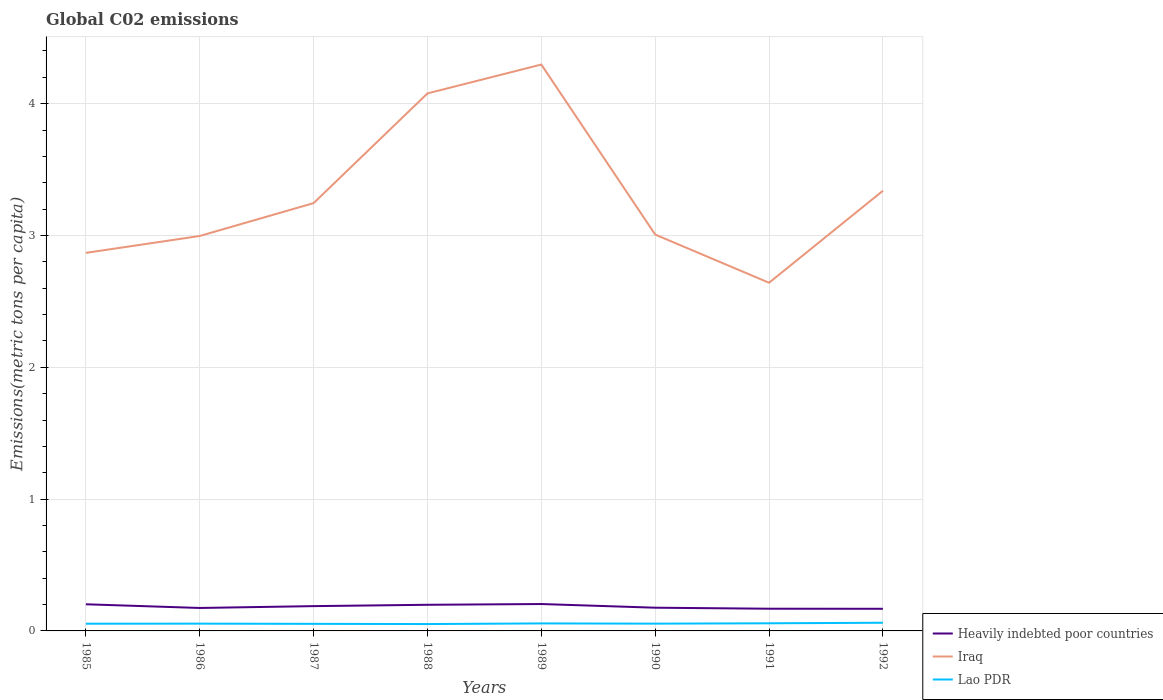How many different coloured lines are there?
Offer a very short reply. 3. Does the line corresponding to Lao PDR intersect with the line corresponding to Iraq?
Your response must be concise. No. Across all years, what is the maximum amount of CO2 emitted in in Lao PDR?
Give a very brief answer. 0.05. What is the total amount of CO2 emitted in in Lao PDR in the graph?
Your response must be concise. 0. What is the difference between the highest and the second highest amount of CO2 emitted in in Lao PDR?
Ensure brevity in your answer.  0.01. What is the difference between the highest and the lowest amount of CO2 emitted in in Lao PDR?
Ensure brevity in your answer.  3. How many lines are there?
Ensure brevity in your answer.  3. How many years are there in the graph?
Keep it short and to the point. 8. Are the values on the major ticks of Y-axis written in scientific E-notation?
Keep it short and to the point. No. Does the graph contain any zero values?
Your answer should be very brief. No. Does the graph contain grids?
Offer a terse response. Yes. How are the legend labels stacked?
Your response must be concise. Vertical. What is the title of the graph?
Keep it short and to the point. Global C02 emissions. Does "Montenegro" appear as one of the legend labels in the graph?
Your answer should be compact. No. What is the label or title of the X-axis?
Your response must be concise. Years. What is the label or title of the Y-axis?
Provide a short and direct response. Emissions(metric tons per capita). What is the Emissions(metric tons per capita) in Heavily indebted poor countries in 1985?
Offer a terse response. 0.2. What is the Emissions(metric tons per capita) of Iraq in 1985?
Provide a succinct answer. 2.87. What is the Emissions(metric tons per capita) in Lao PDR in 1985?
Provide a short and direct response. 0.05. What is the Emissions(metric tons per capita) in Heavily indebted poor countries in 1986?
Your answer should be compact. 0.17. What is the Emissions(metric tons per capita) in Iraq in 1986?
Provide a succinct answer. 3. What is the Emissions(metric tons per capita) in Lao PDR in 1986?
Provide a short and direct response. 0.06. What is the Emissions(metric tons per capita) of Heavily indebted poor countries in 1987?
Your answer should be compact. 0.19. What is the Emissions(metric tons per capita) of Iraq in 1987?
Give a very brief answer. 3.25. What is the Emissions(metric tons per capita) of Lao PDR in 1987?
Offer a very short reply. 0.05. What is the Emissions(metric tons per capita) in Heavily indebted poor countries in 1988?
Provide a succinct answer. 0.2. What is the Emissions(metric tons per capita) in Iraq in 1988?
Provide a short and direct response. 4.08. What is the Emissions(metric tons per capita) of Lao PDR in 1988?
Your response must be concise. 0.05. What is the Emissions(metric tons per capita) of Heavily indebted poor countries in 1989?
Your answer should be compact. 0.2. What is the Emissions(metric tons per capita) in Iraq in 1989?
Provide a succinct answer. 4.3. What is the Emissions(metric tons per capita) in Lao PDR in 1989?
Make the answer very short. 0.06. What is the Emissions(metric tons per capita) in Heavily indebted poor countries in 1990?
Offer a very short reply. 0.18. What is the Emissions(metric tons per capita) of Iraq in 1990?
Ensure brevity in your answer.  3.01. What is the Emissions(metric tons per capita) in Lao PDR in 1990?
Give a very brief answer. 0.06. What is the Emissions(metric tons per capita) of Heavily indebted poor countries in 1991?
Provide a short and direct response. 0.17. What is the Emissions(metric tons per capita) of Iraq in 1991?
Make the answer very short. 2.64. What is the Emissions(metric tons per capita) in Lao PDR in 1991?
Provide a succinct answer. 0.06. What is the Emissions(metric tons per capita) of Heavily indebted poor countries in 1992?
Offer a terse response. 0.17. What is the Emissions(metric tons per capita) in Iraq in 1992?
Provide a succinct answer. 3.34. What is the Emissions(metric tons per capita) in Lao PDR in 1992?
Offer a terse response. 0.06. Across all years, what is the maximum Emissions(metric tons per capita) of Heavily indebted poor countries?
Make the answer very short. 0.2. Across all years, what is the maximum Emissions(metric tons per capita) in Iraq?
Offer a terse response. 4.3. Across all years, what is the maximum Emissions(metric tons per capita) of Lao PDR?
Provide a succinct answer. 0.06. Across all years, what is the minimum Emissions(metric tons per capita) of Heavily indebted poor countries?
Offer a terse response. 0.17. Across all years, what is the minimum Emissions(metric tons per capita) of Iraq?
Provide a short and direct response. 2.64. Across all years, what is the minimum Emissions(metric tons per capita) of Lao PDR?
Provide a short and direct response. 0.05. What is the total Emissions(metric tons per capita) in Heavily indebted poor countries in the graph?
Offer a terse response. 1.48. What is the total Emissions(metric tons per capita) of Iraq in the graph?
Your answer should be compact. 26.47. What is the total Emissions(metric tons per capita) in Lao PDR in the graph?
Provide a short and direct response. 0.45. What is the difference between the Emissions(metric tons per capita) of Heavily indebted poor countries in 1985 and that in 1986?
Ensure brevity in your answer.  0.03. What is the difference between the Emissions(metric tons per capita) in Iraq in 1985 and that in 1986?
Offer a terse response. -0.13. What is the difference between the Emissions(metric tons per capita) of Lao PDR in 1985 and that in 1986?
Offer a terse response. -0. What is the difference between the Emissions(metric tons per capita) in Heavily indebted poor countries in 1985 and that in 1987?
Your answer should be very brief. 0.01. What is the difference between the Emissions(metric tons per capita) of Iraq in 1985 and that in 1987?
Ensure brevity in your answer.  -0.38. What is the difference between the Emissions(metric tons per capita) of Lao PDR in 1985 and that in 1987?
Your response must be concise. 0. What is the difference between the Emissions(metric tons per capita) in Heavily indebted poor countries in 1985 and that in 1988?
Your answer should be compact. 0. What is the difference between the Emissions(metric tons per capita) of Iraq in 1985 and that in 1988?
Make the answer very short. -1.21. What is the difference between the Emissions(metric tons per capita) in Lao PDR in 1985 and that in 1988?
Keep it short and to the point. 0. What is the difference between the Emissions(metric tons per capita) of Heavily indebted poor countries in 1985 and that in 1989?
Your answer should be very brief. -0. What is the difference between the Emissions(metric tons per capita) in Iraq in 1985 and that in 1989?
Your answer should be very brief. -1.43. What is the difference between the Emissions(metric tons per capita) of Lao PDR in 1985 and that in 1989?
Make the answer very short. -0. What is the difference between the Emissions(metric tons per capita) of Heavily indebted poor countries in 1985 and that in 1990?
Provide a short and direct response. 0.03. What is the difference between the Emissions(metric tons per capita) of Iraq in 1985 and that in 1990?
Offer a terse response. -0.14. What is the difference between the Emissions(metric tons per capita) of Lao PDR in 1985 and that in 1990?
Provide a succinct answer. -0. What is the difference between the Emissions(metric tons per capita) of Heavily indebted poor countries in 1985 and that in 1991?
Ensure brevity in your answer.  0.03. What is the difference between the Emissions(metric tons per capita) in Iraq in 1985 and that in 1991?
Give a very brief answer. 0.23. What is the difference between the Emissions(metric tons per capita) in Lao PDR in 1985 and that in 1991?
Offer a terse response. -0. What is the difference between the Emissions(metric tons per capita) of Heavily indebted poor countries in 1985 and that in 1992?
Offer a terse response. 0.03. What is the difference between the Emissions(metric tons per capita) in Iraq in 1985 and that in 1992?
Provide a short and direct response. -0.47. What is the difference between the Emissions(metric tons per capita) of Lao PDR in 1985 and that in 1992?
Provide a succinct answer. -0.01. What is the difference between the Emissions(metric tons per capita) of Heavily indebted poor countries in 1986 and that in 1987?
Make the answer very short. -0.01. What is the difference between the Emissions(metric tons per capita) in Iraq in 1986 and that in 1987?
Provide a short and direct response. -0.25. What is the difference between the Emissions(metric tons per capita) of Lao PDR in 1986 and that in 1987?
Your answer should be very brief. 0. What is the difference between the Emissions(metric tons per capita) of Heavily indebted poor countries in 1986 and that in 1988?
Give a very brief answer. -0.02. What is the difference between the Emissions(metric tons per capita) of Iraq in 1986 and that in 1988?
Your answer should be compact. -1.08. What is the difference between the Emissions(metric tons per capita) in Lao PDR in 1986 and that in 1988?
Make the answer very short. 0. What is the difference between the Emissions(metric tons per capita) of Heavily indebted poor countries in 1986 and that in 1989?
Your answer should be very brief. -0.03. What is the difference between the Emissions(metric tons per capita) of Iraq in 1986 and that in 1989?
Offer a very short reply. -1.3. What is the difference between the Emissions(metric tons per capita) of Lao PDR in 1986 and that in 1989?
Your answer should be very brief. -0. What is the difference between the Emissions(metric tons per capita) of Heavily indebted poor countries in 1986 and that in 1990?
Provide a succinct answer. -0. What is the difference between the Emissions(metric tons per capita) in Iraq in 1986 and that in 1990?
Your response must be concise. -0.01. What is the difference between the Emissions(metric tons per capita) of Heavily indebted poor countries in 1986 and that in 1991?
Your response must be concise. 0.01. What is the difference between the Emissions(metric tons per capita) in Iraq in 1986 and that in 1991?
Give a very brief answer. 0.35. What is the difference between the Emissions(metric tons per capita) of Lao PDR in 1986 and that in 1991?
Your response must be concise. -0. What is the difference between the Emissions(metric tons per capita) of Heavily indebted poor countries in 1986 and that in 1992?
Provide a short and direct response. 0.01. What is the difference between the Emissions(metric tons per capita) of Iraq in 1986 and that in 1992?
Your response must be concise. -0.34. What is the difference between the Emissions(metric tons per capita) of Lao PDR in 1986 and that in 1992?
Ensure brevity in your answer.  -0.01. What is the difference between the Emissions(metric tons per capita) in Heavily indebted poor countries in 1987 and that in 1988?
Your answer should be very brief. -0.01. What is the difference between the Emissions(metric tons per capita) of Iraq in 1987 and that in 1988?
Your response must be concise. -0.83. What is the difference between the Emissions(metric tons per capita) of Lao PDR in 1987 and that in 1988?
Give a very brief answer. 0. What is the difference between the Emissions(metric tons per capita) in Heavily indebted poor countries in 1987 and that in 1989?
Offer a very short reply. -0.02. What is the difference between the Emissions(metric tons per capita) of Iraq in 1987 and that in 1989?
Make the answer very short. -1.05. What is the difference between the Emissions(metric tons per capita) in Lao PDR in 1987 and that in 1989?
Offer a very short reply. -0. What is the difference between the Emissions(metric tons per capita) of Heavily indebted poor countries in 1987 and that in 1990?
Give a very brief answer. 0.01. What is the difference between the Emissions(metric tons per capita) of Iraq in 1987 and that in 1990?
Your response must be concise. 0.24. What is the difference between the Emissions(metric tons per capita) in Lao PDR in 1987 and that in 1990?
Ensure brevity in your answer.  -0. What is the difference between the Emissions(metric tons per capita) of Heavily indebted poor countries in 1987 and that in 1991?
Make the answer very short. 0.02. What is the difference between the Emissions(metric tons per capita) of Iraq in 1987 and that in 1991?
Make the answer very short. 0.6. What is the difference between the Emissions(metric tons per capita) in Lao PDR in 1987 and that in 1991?
Keep it short and to the point. -0. What is the difference between the Emissions(metric tons per capita) of Heavily indebted poor countries in 1987 and that in 1992?
Offer a very short reply. 0.02. What is the difference between the Emissions(metric tons per capita) of Iraq in 1987 and that in 1992?
Ensure brevity in your answer.  -0.09. What is the difference between the Emissions(metric tons per capita) of Lao PDR in 1987 and that in 1992?
Ensure brevity in your answer.  -0.01. What is the difference between the Emissions(metric tons per capita) in Heavily indebted poor countries in 1988 and that in 1989?
Ensure brevity in your answer.  -0.01. What is the difference between the Emissions(metric tons per capita) of Iraq in 1988 and that in 1989?
Make the answer very short. -0.22. What is the difference between the Emissions(metric tons per capita) of Lao PDR in 1988 and that in 1989?
Keep it short and to the point. -0. What is the difference between the Emissions(metric tons per capita) of Heavily indebted poor countries in 1988 and that in 1990?
Provide a short and direct response. 0.02. What is the difference between the Emissions(metric tons per capita) of Iraq in 1988 and that in 1990?
Keep it short and to the point. 1.07. What is the difference between the Emissions(metric tons per capita) in Lao PDR in 1988 and that in 1990?
Your response must be concise. -0. What is the difference between the Emissions(metric tons per capita) of Heavily indebted poor countries in 1988 and that in 1991?
Ensure brevity in your answer.  0.03. What is the difference between the Emissions(metric tons per capita) of Iraq in 1988 and that in 1991?
Give a very brief answer. 1.44. What is the difference between the Emissions(metric tons per capita) in Lao PDR in 1988 and that in 1991?
Provide a succinct answer. -0.01. What is the difference between the Emissions(metric tons per capita) in Heavily indebted poor countries in 1988 and that in 1992?
Offer a terse response. 0.03. What is the difference between the Emissions(metric tons per capita) in Iraq in 1988 and that in 1992?
Keep it short and to the point. 0.74. What is the difference between the Emissions(metric tons per capita) in Lao PDR in 1988 and that in 1992?
Your answer should be very brief. -0.01. What is the difference between the Emissions(metric tons per capita) of Heavily indebted poor countries in 1989 and that in 1990?
Ensure brevity in your answer.  0.03. What is the difference between the Emissions(metric tons per capita) of Iraq in 1989 and that in 1990?
Ensure brevity in your answer.  1.29. What is the difference between the Emissions(metric tons per capita) in Lao PDR in 1989 and that in 1990?
Provide a succinct answer. 0. What is the difference between the Emissions(metric tons per capita) of Heavily indebted poor countries in 1989 and that in 1991?
Ensure brevity in your answer.  0.04. What is the difference between the Emissions(metric tons per capita) of Iraq in 1989 and that in 1991?
Make the answer very short. 1.66. What is the difference between the Emissions(metric tons per capita) of Lao PDR in 1989 and that in 1991?
Provide a short and direct response. -0. What is the difference between the Emissions(metric tons per capita) in Heavily indebted poor countries in 1989 and that in 1992?
Make the answer very short. 0.04. What is the difference between the Emissions(metric tons per capita) in Iraq in 1989 and that in 1992?
Your answer should be very brief. 0.96. What is the difference between the Emissions(metric tons per capita) of Lao PDR in 1989 and that in 1992?
Give a very brief answer. -0.01. What is the difference between the Emissions(metric tons per capita) in Heavily indebted poor countries in 1990 and that in 1991?
Your response must be concise. 0.01. What is the difference between the Emissions(metric tons per capita) of Iraq in 1990 and that in 1991?
Your answer should be compact. 0.37. What is the difference between the Emissions(metric tons per capita) of Lao PDR in 1990 and that in 1991?
Keep it short and to the point. -0. What is the difference between the Emissions(metric tons per capita) of Heavily indebted poor countries in 1990 and that in 1992?
Give a very brief answer. 0.01. What is the difference between the Emissions(metric tons per capita) in Iraq in 1990 and that in 1992?
Give a very brief answer. -0.33. What is the difference between the Emissions(metric tons per capita) in Lao PDR in 1990 and that in 1992?
Make the answer very short. -0.01. What is the difference between the Emissions(metric tons per capita) in Heavily indebted poor countries in 1991 and that in 1992?
Keep it short and to the point. 0. What is the difference between the Emissions(metric tons per capita) in Iraq in 1991 and that in 1992?
Your answer should be compact. -0.7. What is the difference between the Emissions(metric tons per capita) of Lao PDR in 1991 and that in 1992?
Make the answer very short. -0. What is the difference between the Emissions(metric tons per capita) in Heavily indebted poor countries in 1985 and the Emissions(metric tons per capita) in Iraq in 1986?
Ensure brevity in your answer.  -2.79. What is the difference between the Emissions(metric tons per capita) in Heavily indebted poor countries in 1985 and the Emissions(metric tons per capita) in Lao PDR in 1986?
Offer a very short reply. 0.15. What is the difference between the Emissions(metric tons per capita) of Iraq in 1985 and the Emissions(metric tons per capita) of Lao PDR in 1986?
Provide a succinct answer. 2.81. What is the difference between the Emissions(metric tons per capita) of Heavily indebted poor countries in 1985 and the Emissions(metric tons per capita) of Iraq in 1987?
Offer a terse response. -3.04. What is the difference between the Emissions(metric tons per capita) of Heavily indebted poor countries in 1985 and the Emissions(metric tons per capita) of Lao PDR in 1987?
Your response must be concise. 0.15. What is the difference between the Emissions(metric tons per capita) of Iraq in 1985 and the Emissions(metric tons per capita) of Lao PDR in 1987?
Your response must be concise. 2.81. What is the difference between the Emissions(metric tons per capita) of Heavily indebted poor countries in 1985 and the Emissions(metric tons per capita) of Iraq in 1988?
Your answer should be compact. -3.88. What is the difference between the Emissions(metric tons per capita) in Iraq in 1985 and the Emissions(metric tons per capita) in Lao PDR in 1988?
Provide a short and direct response. 2.82. What is the difference between the Emissions(metric tons per capita) in Heavily indebted poor countries in 1985 and the Emissions(metric tons per capita) in Iraq in 1989?
Your response must be concise. -4.09. What is the difference between the Emissions(metric tons per capita) of Heavily indebted poor countries in 1985 and the Emissions(metric tons per capita) of Lao PDR in 1989?
Offer a terse response. 0.15. What is the difference between the Emissions(metric tons per capita) in Iraq in 1985 and the Emissions(metric tons per capita) in Lao PDR in 1989?
Give a very brief answer. 2.81. What is the difference between the Emissions(metric tons per capita) in Heavily indebted poor countries in 1985 and the Emissions(metric tons per capita) in Iraq in 1990?
Make the answer very short. -2.8. What is the difference between the Emissions(metric tons per capita) of Heavily indebted poor countries in 1985 and the Emissions(metric tons per capita) of Lao PDR in 1990?
Offer a very short reply. 0.15. What is the difference between the Emissions(metric tons per capita) of Iraq in 1985 and the Emissions(metric tons per capita) of Lao PDR in 1990?
Provide a succinct answer. 2.81. What is the difference between the Emissions(metric tons per capita) of Heavily indebted poor countries in 1985 and the Emissions(metric tons per capita) of Iraq in 1991?
Your response must be concise. -2.44. What is the difference between the Emissions(metric tons per capita) of Heavily indebted poor countries in 1985 and the Emissions(metric tons per capita) of Lao PDR in 1991?
Your answer should be compact. 0.14. What is the difference between the Emissions(metric tons per capita) in Iraq in 1985 and the Emissions(metric tons per capita) in Lao PDR in 1991?
Provide a short and direct response. 2.81. What is the difference between the Emissions(metric tons per capita) of Heavily indebted poor countries in 1985 and the Emissions(metric tons per capita) of Iraq in 1992?
Make the answer very short. -3.14. What is the difference between the Emissions(metric tons per capita) of Heavily indebted poor countries in 1985 and the Emissions(metric tons per capita) of Lao PDR in 1992?
Offer a very short reply. 0.14. What is the difference between the Emissions(metric tons per capita) of Iraq in 1985 and the Emissions(metric tons per capita) of Lao PDR in 1992?
Provide a short and direct response. 2.81. What is the difference between the Emissions(metric tons per capita) in Heavily indebted poor countries in 1986 and the Emissions(metric tons per capita) in Iraq in 1987?
Provide a short and direct response. -3.07. What is the difference between the Emissions(metric tons per capita) in Heavily indebted poor countries in 1986 and the Emissions(metric tons per capita) in Lao PDR in 1987?
Give a very brief answer. 0.12. What is the difference between the Emissions(metric tons per capita) of Iraq in 1986 and the Emissions(metric tons per capita) of Lao PDR in 1987?
Offer a terse response. 2.94. What is the difference between the Emissions(metric tons per capita) in Heavily indebted poor countries in 1986 and the Emissions(metric tons per capita) in Iraq in 1988?
Your response must be concise. -3.9. What is the difference between the Emissions(metric tons per capita) in Heavily indebted poor countries in 1986 and the Emissions(metric tons per capita) in Lao PDR in 1988?
Your answer should be very brief. 0.12. What is the difference between the Emissions(metric tons per capita) of Iraq in 1986 and the Emissions(metric tons per capita) of Lao PDR in 1988?
Your answer should be very brief. 2.94. What is the difference between the Emissions(metric tons per capita) in Heavily indebted poor countries in 1986 and the Emissions(metric tons per capita) in Iraq in 1989?
Provide a succinct answer. -4.12. What is the difference between the Emissions(metric tons per capita) in Heavily indebted poor countries in 1986 and the Emissions(metric tons per capita) in Lao PDR in 1989?
Your answer should be compact. 0.12. What is the difference between the Emissions(metric tons per capita) of Iraq in 1986 and the Emissions(metric tons per capita) of Lao PDR in 1989?
Offer a terse response. 2.94. What is the difference between the Emissions(metric tons per capita) in Heavily indebted poor countries in 1986 and the Emissions(metric tons per capita) in Iraq in 1990?
Provide a short and direct response. -2.83. What is the difference between the Emissions(metric tons per capita) of Heavily indebted poor countries in 1986 and the Emissions(metric tons per capita) of Lao PDR in 1990?
Your answer should be compact. 0.12. What is the difference between the Emissions(metric tons per capita) of Iraq in 1986 and the Emissions(metric tons per capita) of Lao PDR in 1990?
Give a very brief answer. 2.94. What is the difference between the Emissions(metric tons per capita) in Heavily indebted poor countries in 1986 and the Emissions(metric tons per capita) in Iraq in 1991?
Provide a short and direct response. -2.47. What is the difference between the Emissions(metric tons per capita) of Heavily indebted poor countries in 1986 and the Emissions(metric tons per capita) of Lao PDR in 1991?
Give a very brief answer. 0.12. What is the difference between the Emissions(metric tons per capita) in Iraq in 1986 and the Emissions(metric tons per capita) in Lao PDR in 1991?
Make the answer very short. 2.94. What is the difference between the Emissions(metric tons per capita) in Heavily indebted poor countries in 1986 and the Emissions(metric tons per capita) in Iraq in 1992?
Make the answer very short. -3.17. What is the difference between the Emissions(metric tons per capita) in Heavily indebted poor countries in 1986 and the Emissions(metric tons per capita) in Lao PDR in 1992?
Give a very brief answer. 0.11. What is the difference between the Emissions(metric tons per capita) of Iraq in 1986 and the Emissions(metric tons per capita) of Lao PDR in 1992?
Make the answer very short. 2.93. What is the difference between the Emissions(metric tons per capita) in Heavily indebted poor countries in 1987 and the Emissions(metric tons per capita) in Iraq in 1988?
Your answer should be very brief. -3.89. What is the difference between the Emissions(metric tons per capita) of Heavily indebted poor countries in 1987 and the Emissions(metric tons per capita) of Lao PDR in 1988?
Your answer should be very brief. 0.14. What is the difference between the Emissions(metric tons per capita) in Iraq in 1987 and the Emissions(metric tons per capita) in Lao PDR in 1988?
Ensure brevity in your answer.  3.19. What is the difference between the Emissions(metric tons per capita) in Heavily indebted poor countries in 1987 and the Emissions(metric tons per capita) in Iraq in 1989?
Offer a very short reply. -4.11. What is the difference between the Emissions(metric tons per capita) in Heavily indebted poor countries in 1987 and the Emissions(metric tons per capita) in Lao PDR in 1989?
Provide a short and direct response. 0.13. What is the difference between the Emissions(metric tons per capita) of Iraq in 1987 and the Emissions(metric tons per capita) of Lao PDR in 1989?
Make the answer very short. 3.19. What is the difference between the Emissions(metric tons per capita) in Heavily indebted poor countries in 1987 and the Emissions(metric tons per capita) in Iraq in 1990?
Offer a terse response. -2.82. What is the difference between the Emissions(metric tons per capita) of Heavily indebted poor countries in 1987 and the Emissions(metric tons per capita) of Lao PDR in 1990?
Provide a short and direct response. 0.13. What is the difference between the Emissions(metric tons per capita) of Iraq in 1987 and the Emissions(metric tons per capita) of Lao PDR in 1990?
Give a very brief answer. 3.19. What is the difference between the Emissions(metric tons per capita) of Heavily indebted poor countries in 1987 and the Emissions(metric tons per capita) of Iraq in 1991?
Give a very brief answer. -2.45. What is the difference between the Emissions(metric tons per capita) in Heavily indebted poor countries in 1987 and the Emissions(metric tons per capita) in Lao PDR in 1991?
Offer a terse response. 0.13. What is the difference between the Emissions(metric tons per capita) in Iraq in 1987 and the Emissions(metric tons per capita) in Lao PDR in 1991?
Ensure brevity in your answer.  3.19. What is the difference between the Emissions(metric tons per capita) in Heavily indebted poor countries in 1987 and the Emissions(metric tons per capita) in Iraq in 1992?
Your answer should be very brief. -3.15. What is the difference between the Emissions(metric tons per capita) of Heavily indebted poor countries in 1987 and the Emissions(metric tons per capita) of Lao PDR in 1992?
Provide a short and direct response. 0.13. What is the difference between the Emissions(metric tons per capita) in Iraq in 1987 and the Emissions(metric tons per capita) in Lao PDR in 1992?
Offer a very short reply. 3.18. What is the difference between the Emissions(metric tons per capita) in Heavily indebted poor countries in 1988 and the Emissions(metric tons per capita) in Iraq in 1989?
Offer a very short reply. -4.1. What is the difference between the Emissions(metric tons per capita) of Heavily indebted poor countries in 1988 and the Emissions(metric tons per capita) of Lao PDR in 1989?
Offer a very short reply. 0.14. What is the difference between the Emissions(metric tons per capita) in Iraq in 1988 and the Emissions(metric tons per capita) in Lao PDR in 1989?
Your response must be concise. 4.02. What is the difference between the Emissions(metric tons per capita) in Heavily indebted poor countries in 1988 and the Emissions(metric tons per capita) in Iraq in 1990?
Offer a very short reply. -2.81. What is the difference between the Emissions(metric tons per capita) of Heavily indebted poor countries in 1988 and the Emissions(metric tons per capita) of Lao PDR in 1990?
Offer a very short reply. 0.14. What is the difference between the Emissions(metric tons per capita) in Iraq in 1988 and the Emissions(metric tons per capita) in Lao PDR in 1990?
Offer a terse response. 4.02. What is the difference between the Emissions(metric tons per capita) in Heavily indebted poor countries in 1988 and the Emissions(metric tons per capita) in Iraq in 1991?
Give a very brief answer. -2.44. What is the difference between the Emissions(metric tons per capita) of Heavily indebted poor countries in 1988 and the Emissions(metric tons per capita) of Lao PDR in 1991?
Your answer should be compact. 0.14. What is the difference between the Emissions(metric tons per capita) of Iraq in 1988 and the Emissions(metric tons per capita) of Lao PDR in 1991?
Provide a short and direct response. 4.02. What is the difference between the Emissions(metric tons per capita) in Heavily indebted poor countries in 1988 and the Emissions(metric tons per capita) in Iraq in 1992?
Provide a short and direct response. -3.14. What is the difference between the Emissions(metric tons per capita) of Heavily indebted poor countries in 1988 and the Emissions(metric tons per capita) of Lao PDR in 1992?
Offer a terse response. 0.14. What is the difference between the Emissions(metric tons per capita) in Iraq in 1988 and the Emissions(metric tons per capita) in Lao PDR in 1992?
Offer a terse response. 4.02. What is the difference between the Emissions(metric tons per capita) of Heavily indebted poor countries in 1989 and the Emissions(metric tons per capita) of Iraq in 1990?
Your answer should be very brief. -2.8. What is the difference between the Emissions(metric tons per capita) of Heavily indebted poor countries in 1989 and the Emissions(metric tons per capita) of Lao PDR in 1990?
Give a very brief answer. 0.15. What is the difference between the Emissions(metric tons per capita) of Iraq in 1989 and the Emissions(metric tons per capita) of Lao PDR in 1990?
Keep it short and to the point. 4.24. What is the difference between the Emissions(metric tons per capita) in Heavily indebted poor countries in 1989 and the Emissions(metric tons per capita) in Iraq in 1991?
Your answer should be compact. -2.44. What is the difference between the Emissions(metric tons per capita) in Heavily indebted poor countries in 1989 and the Emissions(metric tons per capita) in Lao PDR in 1991?
Offer a terse response. 0.15. What is the difference between the Emissions(metric tons per capita) of Iraq in 1989 and the Emissions(metric tons per capita) of Lao PDR in 1991?
Offer a terse response. 4.24. What is the difference between the Emissions(metric tons per capita) in Heavily indebted poor countries in 1989 and the Emissions(metric tons per capita) in Iraq in 1992?
Your answer should be compact. -3.14. What is the difference between the Emissions(metric tons per capita) of Heavily indebted poor countries in 1989 and the Emissions(metric tons per capita) of Lao PDR in 1992?
Your answer should be very brief. 0.14. What is the difference between the Emissions(metric tons per capita) in Iraq in 1989 and the Emissions(metric tons per capita) in Lao PDR in 1992?
Your answer should be compact. 4.23. What is the difference between the Emissions(metric tons per capita) of Heavily indebted poor countries in 1990 and the Emissions(metric tons per capita) of Iraq in 1991?
Offer a terse response. -2.47. What is the difference between the Emissions(metric tons per capita) of Heavily indebted poor countries in 1990 and the Emissions(metric tons per capita) of Lao PDR in 1991?
Provide a succinct answer. 0.12. What is the difference between the Emissions(metric tons per capita) in Iraq in 1990 and the Emissions(metric tons per capita) in Lao PDR in 1991?
Provide a short and direct response. 2.95. What is the difference between the Emissions(metric tons per capita) in Heavily indebted poor countries in 1990 and the Emissions(metric tons per capita) in Iraq in 1992?
Give a very brief answer. -3.16. What is the difference between the Emissions(metric tons per capita) in Heavily indebted poor countries in 1990 and the Emissions(metric tons per capita) in Lao PDR in 1992?
Your answer should be very brief. 0.11. What is the difference between the Emissions(metric tons per capita) in Iraq in 1990 and the Emissions(metric tons per capita) in Lao PDR in 1992?
Your answer should be very brief. 2.94. What is the difference between the Emissions(metric tons per capita) of Heavily indebted poor countries in 1991 and the Emissions(metric tons per capita) of Iraq in 1992?
Your answer should be compact. -3.17. What is the difference between the Emissions(metric tons per capita) of Heavily indebted poor countries in 1991 and the Emissions(metric tons per capita) of Lao PDR in 1992?
Give a very brief answer. 0.11. What is the difference between the Emissions(metric tons per capita) of Iraq in 1991 and the Emissions(metric tons per capita) of Lao PDR in 1992?
Offer a terse response. 2.58. What is the average Emissions(metric tons per capita) in Heavily indebted poor countries per year?
Offer a terse response. 0.18. What is the average Emissions(metric tons per capita) in Iraq per year?
Your answer should be very brief. 3.31. What is the average Emissions(metric tons per capita) of Lao PDR per year?
Offer a very short reply. 0.06. In the year 1985, what is the difference between the Emissions(metric tons per capita) in Heavily indebted poor countries and Emissions(metric tons per capita) in Iraq?
Your answer should be compact. -2.67. In the year 1985, what is the difference between the Emissions(metric tons per capita) in Heavily indebted poor countries and Emissions(metric tons per capita) in Lao PDR?
Your answer should be very brief. 0.15. In the year 1985, what is the difference between the Emissions(metric tons per capita) of Iraq and Emissions(metric tons per capita) of Lao PDR?
Your answer should be very brief. 2.81. In the year 1986, what is the difference between the Emissions(metric tons per capita) of Heavily indebted poor countries and Emissions(metric tons per capita) of Iraq?
Offer a terse response. -2.82. In the year 1986, what is the difference between the Emissions(metric tons per capita) in Heavily indebted poor countries and Emissions(metric tons per capita) in Lao PDR?
Keep it short and to the point. 0.12. In the year 1986, what is the difference between the Emissions(metric tons per capita) of Iraq and Emissions(metric tons per capita) of Lao PDR?
Your response must be concise. 2.94. In the year 1987, what is the difference between the Emissions(metric tons per capita) of Heavily indebted poor countries and Emissions(metric tons per capita) of Iraq?
Ensure brevity in your answer.  -3.06. In the year 1987, what is the difference between the Emissions(metric tons per capita) of Heavily indebted poor countries and Emissions(metric tons per capita) of Lao PDR?
Keep it short and to the point. 0.13. In the year 1987, what is the difference between the Emissions(metric tons per capita) of Iraq and Emissions(metric tons per capita) of Lao PDR?
Provide a short and direct response. 3.19. In the year 1988, what is the difference between the Emissions(metric tons per capita) in Heavily indebted poor countries and Emissions(metric tons per capita) in Iraq?
Offer a terse response. -3.88. In the year 1988, what is the difference between the Emissions(metric tons per capita) of Heavily indebted poor countries and Emissions(metric tons per capita) of Lao PDR?
Keep it short and to the point. 0.15. In the year 1988, what is the difference between the Emissions(metric tons per capita) of Iraq and Emissions(metric tons per capita) of Lao PDR?
Ensure brevity in your answer.  4.03. In the year 1989, what is the difference between the Emissions(metric tons per capita) of Heavily indebted poor countries and Emissions(metric tons per capita) of Iraq?
Provide a succinct answer. -4.09. In the year 1989, what is the difference between the Emissions(metric tons per capita) in Heavily indebted poor countries and Emissions(metric tons per capita) in Lao PDR?
Give a very brief answer. 0.15. In the year 1989, what is the difference between the Emissions(metric tons per capita) in Iraq and Emissions(metric tons per capita) in Lao PDR?
Keep it short and to the point. 4.24. In the year 1990, what is the difference between the Emissions(metric tons per capita) of Heavily indebted poor countries and Emissions(metric tons per capita) of Iraq?
Your answer should be very brief. -2.83. In the year 1990, what is the difference between the Emissions(metric tons per capita) of Heavily indebted poor countries and Emissions(metric tons per capita) of Lao PDR?
Offer a terse response. 0.12. In the year 1990, what is the difference between the Emissions(metric tons per capita) in Iraq and Emissions(metric tons per capita) in Lao PDR?
Make the answer very short. 2.95. In the year 1991, what is the difference between the Emissions(metric tons per capita) of Heavily indebted poor countries and Emissions(metric tons per capita) of Iraq?
Your answer should be compact. -2.47. In the year 1991, what is the difference between the Emissions(metric tons per capita) in Heavily indebted poor countries and Emissions(metric tons per capita) in Lao PDR?
Keep it short and to the point. 0.11. In the year 1991, what is the difference between the Emissions(metric tons per capita) of Iraq and Emissions(metric tons per capita) of Lao PDR?
Make the answer very short. 2.58. In the year 1992, what is the difference between the Emissions(metric tons per capita) in Heavily indebted poor countries and Emissions(metric tons per capita) in Iraq?
Your answer should be compact. -3.17. In the year 1992, what is the difference between the Emissions(metric tons per capita) of Heavily indebted poor countries and Emissions(metric tons per capita) of Lao PDR?
Provide a short and direct response. 0.11. In the year 1992, what is the difference between the Emissions(metric tons per capita) in Iraq and Emissions(metric tons per capita) in Lao PDR?
Offer a terse response. 3.28. What is the ratio of the Emissions(metric tons per capita) of Heavily indebted poor countries in 1985 to that in 1986?
Give a very brief answer. 1.16. What is the ratio of the Emissions(metric tons per capita) in Iraq in 1985 to that in 1986?
Give a very brief answer. 0.96. What is the ratio of the Emissions(metric tons per capita) of Lao PDR in 1985 to that in 1986?
Your response must be concise. 0.99. What is the ratio of the Emissions(metric tons per capita) in Heavily indebted poor countries in 1985 to that in 1987?
Your answer should be very brief. 1.07. What is the ratio of the Emissions(metric tons per capita) of Iraq in 1985 to that in 1987?
Make the answer very short. 0.88. What is the ratio of the Emissions(metric tons per capita) of Lao PDR in 1985 to that in 1987?
Ensure brevity in your answer.  1.02. What is the ratio of the Emissions(metric tons per capita) in Heavily indebted poor countries in 1985 to that in 1988?
Keep it short and to the point. 1.02. What is the ratio of the Emissions(metric tons per capita) of Iraq in 1985 to that in 1988?
Make the answer very short. 0.7. What is the ratio of the Emissions(metric tons per capita) of Lao PDR in 1985 to that in 1988?
Offer a very short reply. 1.05. What is the ratio of the Emissions(metric tons per capita) in Heavily indebted poor countries in 1985 to that in 1989?
Your answer should be very brief. 0.99. What is the ratio of the Emissions(metric tons per capita) of Iraq in 1985 to that in 1989?
Offer a very short reply. 0.67. What is the ratio of the Emissions(metric tons per capita) of Lao PDR in 1985 to that in 1989?
Provide a succinct answer. 0.96. What is the ratio of the Emissions(metric tons per capita) of Heavily indebted poor countries in 1985 to that in 1990?
Offer a terse response. 1.15. What is the ratio of the Emissions(metric tons per capita) of Iraq in 1985 to that in 1990?
Provide a succinct answer. 0.95. What is the ratio of the Emissions(metric tons per capita) in Lao PDR in 1985 to that in 1990?
Provide a succinct answer. 0.99. What is the ratio of the Emissions(metric tons per capita) in Heavily indebted poor countries in 1985 to that in 1991?
Your answer should be compact. 1.2. What is the ratio of the Emissions(metric tons per capita) in Iraq in 1985 to that in 1991?
Offer a terse response. 1.09. What is the ratio of the Emissions(metric tons per capita) in Lao PDR in 1985 to that in 1991?
Offer a terse response. 0.95. What is the ratio of the Emissions(metric tons per capita) in Heavily indebted poor countries in 1985 to that in 1992?
Offer a terse response. 1.2. What is the ratio of the Emissions(metric tons per capita) of Iraq in 1985 to that in 1992?
Ensure brevity in your answer.  0.86. What is the ratio of the Emissions(metric tons per capita) of Lao PDR in 1985 to that in 1992?
Provide a succinct answer. 0.88. What is the ratio of the Emissions(metric tons per capita) of Heavily indebted poor countries in 1986 to that in 1987?
Keep it short and to the point. 0.93. What is the ratio of the Emissions(metric tons per capita) in Iraq in 1986 to that in 1987?
Offer a very short reply. 0.92. What is the ratio of the Emissions(metric tons per capita) in Heavily indebted poor countries in 1986 to that in 1988?
Your answer should be very brief. 0.88. What is the ratio of the Emissions(metric tons per capita) of Iraq in 1986 to that in 1988?
Provide a succinct answer. 0.73. What is the ratio of the Emissions(metric tons per capita) in Lao PDR in 1986 to that in 1988?
Your answer should be compact. 1.06. What is the ratio of the Emissions(metric tons per capita) of Heavily indebted poor countries in 1986 to that in 1989?
Provide a short and direct response. 0.85. What is the ratio of the Emissions(metric tons per capita) of Iraq in 1986 to that in 1989?
Your answer should be very brief. 0.7. What is the ratio of the Emissions(metric tons per capita) in Heavily indebted poor countries in 1986 to that in 1990?
Make the answer very short. 0.99. What is the ratio of the Emissions(metric tons per capita) of Heavily indebted poor countries in 1986 to that in 1991?
Provide a short and direct response. 1.03. What is the ratio of the Emissions(metric tons per capita) of Iraq in 1986 to that in 1991?
Ensure brevity in your answer.  1.13. What is the ratio of the Emissions(metric tons per capita) in Lao PDR in 1986 to that in 1991?
Provide a succinct answer. 0.95. What is the ratio of the Emissions(metric tons per capita) in Heavily indebted poor countries in 1986 to that in 1992?
Provide a short and direct response. 1.04. What is the ratio of the Emissions(metric tons per capita) of Iraq in 1986 to that in 1992?
Your answer should be compact. 0.9. What is the ratio of the Emissions(metric tons per capita) in Lao PDR in 1986 to that in 1992?
Your response must be concise. 0.89. What is the ratio of the Emissions(metric tons per capita) in Heavily indebted poor countries in 1987 to that in 1988?
Give a very brief answer. 0.95. What is the ratio of the Emissions(metric tons per capita) in Iraq in 1987 to that in 1988?
Ensure brevity in your answer.  0.8. What is the ratio of the Emissions(metric tons per capita) of Lao PDR in 1987 to that in 1988?
Provide a succinct answer. 1.03. What is the ratio of the Emissions(metric tons per capita) of Heavily indebted poor countries in 1987 to that in 1989?
Make the answer very short. 0.92. What is the ratio of the Emissions(metric tons per capita) of Iraq in 1987 to that in 1989?
Offer a very short reply. 0.76. What is the ratio of the Emissions(metric tons per capita) in Lao PDR in 1987 to that in 1989?
Ensure brevity in your answer.  0.94. What is the ratio of the Emissions(metric tons per capita) of Heavily indebted poor countries in 1987 to that in 1990?
Offer a very short reply. 1.07. What is the ratio of the Emissions(metric tons per capita) of Iraq in 1987 to that in 1990?
Your response must be concise. 1.08. What is the ratio of the Emissions(metric tons per capita) in Lao PDR in 1987 to that in 1990?
Give a very brief answer. 0.97. What is the ratio of the Emissions(metric tons per capita) in Heavily indebted poor countries in 1987 to that in 1991?
Provide a succinct answer. 1.12. What is the ratio of the Emissions(metric tons per capita) of Iraq in 1987 to that in 1991?
Make the answer very short. 1.23. What is the ratio of the Emissions(metric tons per capita) of Lao PDR in 1987 to that in 1991?
Give a very brief answer. 0.93. What is the ratio of the Emissions(metric tons per capita) in Heavily indebted poor countries in 1987 to that in 1992?
Give a very brief answer. 1.12. What is the ratio of the Emissions(metric tons per capita) of Iraq in 1987 to that in 1992?
Your answer should be compact. 0.97. What is the ratio of the Emissions(metric tons per capita) of Lao PDR in 1987 to that in 1992?
Give a very brief answer. 0.87. What is the ratio of the Emissions(metric tons per capita) of Heavily indebted poor countries in 1988 to that in 1989?
Ensure brevity in your answer.  0.97. What is the ratio of the Emissions(metric tons per capita) of Iraq in 1988 to that in 1989?
Offer a terse response. 0.95. What is the ratio of the Emissions(metric tons per capita) of Lao PDR in 1988 to that in 1989?
Give a very brief answer. 0.92. What is the ratio of the Emissions(metric tons per capita) of Heavily indebted poor countries in 1988 to that in 1990?
Provide a succinct answer. 1.13. What is the ratio of the Emissions(metric tons per capita) in Iraq in 1988 to that in 1990?
Your response must be concise. 1.36. What is the ratio of the Emissions(metric tons per capita) of Lao PDR in 1988 to that in 1990?
Provide a short and direct response. 0.94. What is the ratio of the Emissions(metric tons per capita) of Heavily indebted poor countries in 1988 to that in 1991?
Provide a short and direct response. 1.18. What is the ratio of the Emissions(metric tons per capita) in Iraq in 1988 to that in 1991?
Ensure brevity in your answer.  1.54. What is the ratio of the Emissions(metric tons per capita) of Lao PDR in 1988 to that in 1991?
Your answer should be compact. 0.9. What is the ratio of the Emissions(metric tons per capita) of Heavily indebted poor countries in 1988 to that in 1992?
Your response must be concise. 1.18. What is the ratio of the Emissions(metric tons per capita) in Iraq in 1988 to that in 1992?
Keep it short and to the point. 1.22. What is the ratio of the Emissions(metric tons per capita) of Lao PDR in 1988 to that in 1992?
Offer a terse response. 0.84. What is the ratio of the Emissions(metric tons per capita) in Heavily indebted poor countries in 1989 to that in 1990?
Make the answer very short. 1.16. What is the ratio of the Emissions(metric tons per capita) in Iraq in 1989 to that in 1990?
Your answer should be very brief. 1.43. What is the ratio of the Emissions(metric tons per capita) of Lao PDR in 1989 to that in 1990?
Offer a terse response. 1.03. What is the ratio of the Emissions(metric tons per capita) of Heavily indebted poor countries in 1989 to that in 1991?
Keep it short and to the point. 1.21. What is the ratio of the Emissions(metric tons per capita) in Iraq in 1989 to that in 1991?
Make the answer very short. 1.63. What is the ratio of the Emissions(metric tons per capita) of Lao PDR in 1989 to that in 1991?
Ensure brevity in your answer.  0.98. What is the ratio of the Emissions(metric tons per capita) in Heavily indebted poor countries in 1989 to that in 1992?
Make the answer very short. 1.22. What is the ratio of the Emissions(metric tons per capita) of Iraq in 1989 to that in 1992?
Make the answer very short. 1.29. What is the ratio of the Emissions(metric tons per capita) of Lao PDR in 1989 to that in 1992?
Your answer should be very brief. 0.92. What is the ratio of the Emissions(metric tons per capita) of Heavily indebted poor countries in 1990 to that in 1991?
Offer a terse response. 1.05. What is the ratio of the Emissions(metric tons per capita) of Iraq in 1990 to that in 1991?
Make the answer very short. 1.14. What is the ratio of the Emissions(metric tons per capita) of Lao PDR in 1990 to that in 1991?
Make the answer very short. 0.95. What is the ratio of the Emissions(metric tons per capita) of Heavily indebted poor countries in 1990 to that in 1992?
Your answer should be compact. 1.05. What is the ratio of the Emissions(metric tons per capita) in Iraq in 1990 to that in 1992?
Your answer should be compact. 0.9. What is the ratio of the Emissions(metric tons per capita) in Lao PDR in 1990 to that in 1992?
Offer a terse response. 0.89. What is the ratio of the Emissions(metric tons per capita) of Iraq in 1991 to that in 1992?
Offer a very short reply. 0.79. What is the ratio of the Emissions(metric tons per capita) in Lao PDR in 1991 to that in 1992?
Ensure brevity in your answer.  0.93. What is the difference between the highest and the second highest Emissions(metric tons per capita) in Heavily indebted poor countries?
Ensure brevity in your answer.  0. What is the difference between the highest and the second highest Emissions(metric tons per capita) of Iraq?
Your response must be concise. 0.22. What is the difference between the highest and the second highest Emissions(metric tons per capita) of Lao PDR?
Your response must be concise. 0. What is the difference between the highest and the lowest Emissions(metric tons per capita) of Heavily indebted poor countries?
Keep it short and to the point. 0.04. What is the difference between the highest and the lowest Emissions(metric tons per capita) of Iraq?
Offer a very short reply. 1.66. What is the difference between the highest and the lowest Emissions(metric tons per capita) of Lao PDR?
Your answer should be very brief. 0.01. 